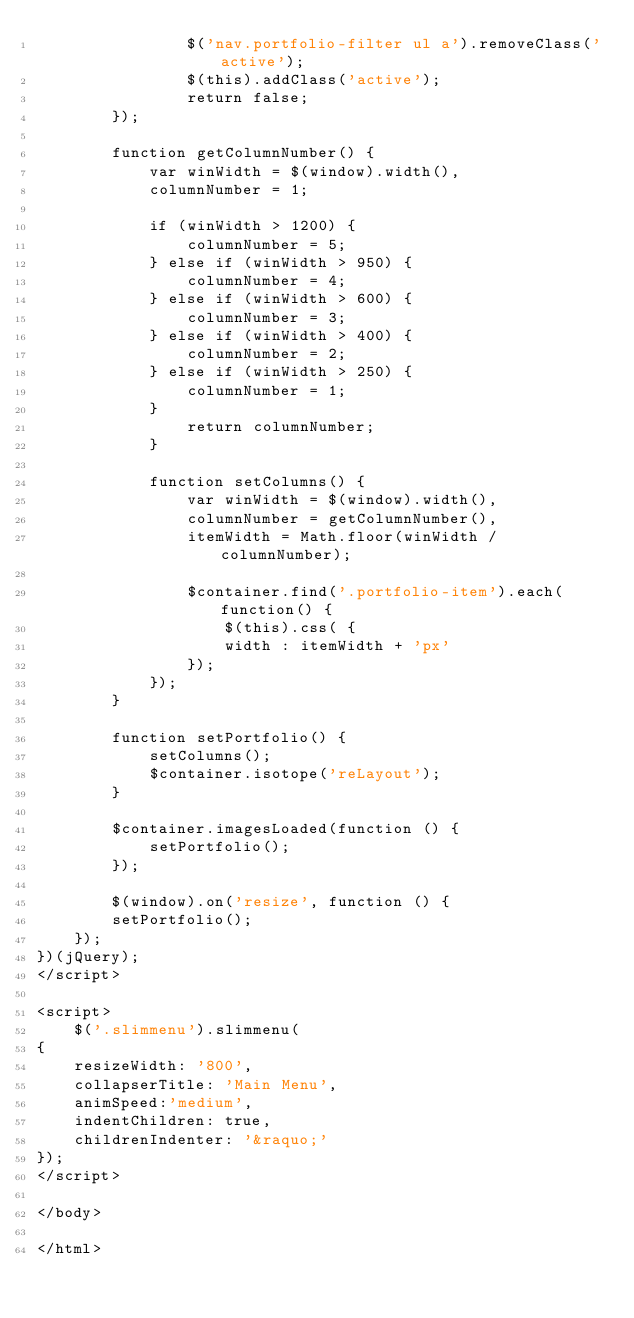<code> <loc_0><loc_0><loc_500><loc_500><_HTML_>				$('nav.portfolio-filter ul a').removeClass('active');
				$(this).addClass('active');
				return false;
		});
		
		function getColumnNumber() { 
			var winWidth = $(window).width(), 
			columnNumber = 1;
		
			if (winWidth > 1200) {
				columnNumber = 5;
			} else if (winWidth > 950) {
				columnNumber = 4;
			} else if (winWidth > 600) {
				columnNumber = 3;
			} else if (winWidth > 400) {
				columnNumber = 2;
			} else if (winWidth > 250) {
				columnNumber = 1;
			}
				return columnNumber;
			}       
			
			function setColumns() {
				var winWidth = $(window).width(), 
				columnNumber = getColumnNumber(), 
				itemWidth = Math.floor(winWidth / columnNumber);
				
				$container.find('.portfolio-item').each(function() { 
					$(this).css( { 
					width : itemWidth + 'px' 
				});
			});
		}
		
		function setPortfolio() { 
			setColumns();
			$container.isotope('reLayout');
		}
			
		$container.imagesLoaded(function () { 
			setPortfolio();
		});
		
		$(window).on('resize', function () { 
		setPortfolio();          
	});
})(jQuery);
</script>

<script>
	$('.slimmenu').slimmenu(
{
    resizeWidth: '800',
    collapserTitle: 'Main Menu',
    animSpeed:'medium',
    indentChildren: true,
    childrenIndenter: '&raquo;'
});
</script>

</body>

</html></code> 